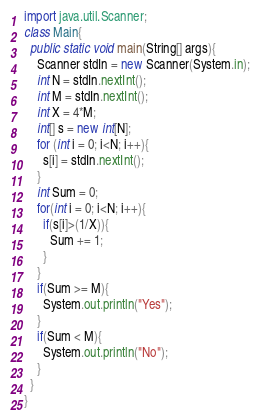<code> <loc_0><loc_0><loc_500><loc_500><_Java_>import java.util.Scanner;
class Main{
  public static void main(String[] args){
    Scanner stdIn = new Scanner(System.in);
    int N = stdIn.nextInt();
    int M = stdIn.nextInt();
    int X = 4*M;
    int[] s = new int[N];
    for (int i = 0; i<N; i++){
      s[i] = stdIn.nextInt();
    }
    int Sum = 0;
    for(int i = 0; i<N; i++){
      if(s[i]>(1/X)){
        Sum += 1;
      }
    }
    if(Sum >= M){
      System.out.println("Yes");
    }
    if(Sum < M){
      System.out.println("No");
    }
  }
}</code> 